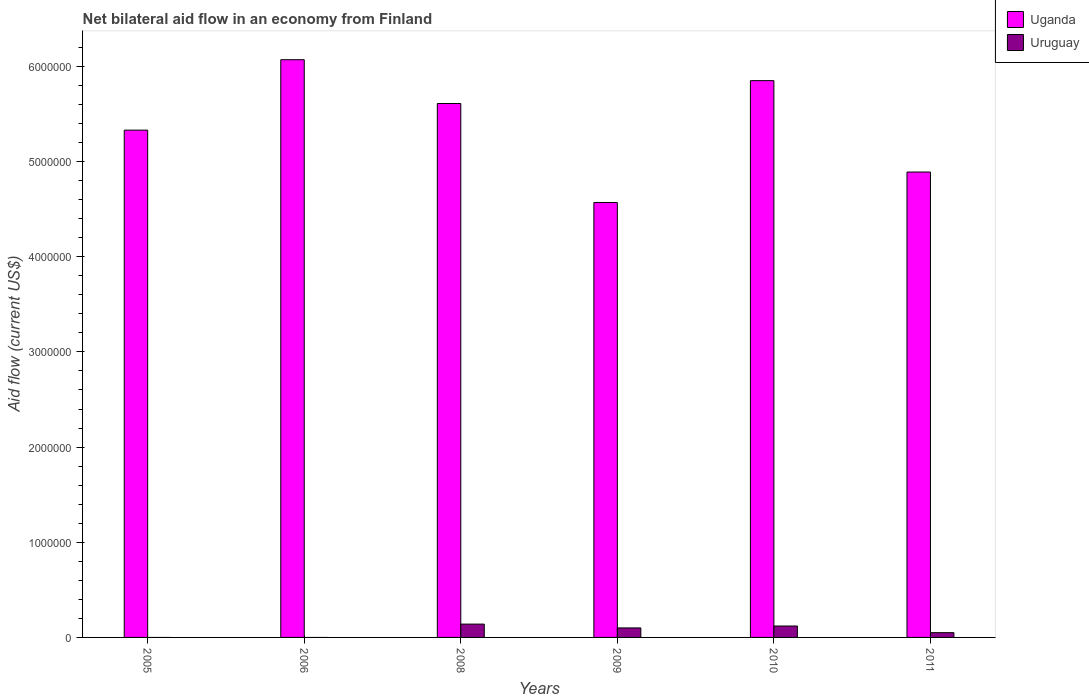Are the number of bars on each tick of the X-axis equal?
Keep it short and to the point. No. What is the label of the 1st group of bars from the left?
Ensure brevity in your answer.  2005. What is the net bilateral aid flow in Uganda in 2009?
Your answer should be compact. 4.57e+06. Across all years, what is the maximum net bilateral aid flow in Uruguay?
Provide a short and direct response. 1.40e+05. Across all years, what is the minimum net bilateral aid flow in Uganda?
Offer a terse response. 4.57e+06. What is the difference between the net bilateral aid flow in Uganda in 2011 and the net bilateral aid flow in Uruguay in 2008?
Offer a very short reply. 4.75e+06. What is the average net bilateral aid flow in Uganda per year?
Keep it short and to the point. 5.39e+06. In the year 2009, what is the difference between the net bilateral aid flow in Uruguay and net bilateral aid flow in Uganda?
Make the answer very short. -4.47e+06. What is the ratio of the net bilateral aid flow in Uganda in 2005 to that in 2006?
Make the answer very short. 0.88. Is the net bilateral aid flow in Uganda in 2010 less than that in 2011?
Offer a terse response. No. Is the difference between the net bilateral aid flow in Uruguay in 2008 and 2009 greater than the difference between the net bilateral aid flow in Uganda in 2008 and 2009?
Make the answer very short. No. What is the difference between the highest and the second highest net bilateral aid flow in Uganda?
Your response must be concise. 2.20e+05. How many bars are there?
Provide a succinct answer. 10. Are all the bars in the graph horizontal?
Your answer should be very brief. No. What is the difference between two consecutive major ticks on the Y-axis?
Your answer should be compact. 1.00e+06. Does the graph contain grids?
Give a very brief answer. No. How many legend labels are there?
Your answer should be very brief. 2. How are the legend labels stacked?
Offer a very short reply. Vertical. What is the title of the graph?
Your answer should be compact. Net bilateral aid flow in an economy from Finland. What is the label or title of the Y-axis?
Provide a succinct answer. Aid flow (current US$). What is the Aid flow (current US$) in Uganda in 2005?
Ensure brevity in your answer.  5.33e+06. What is the Aid flow (current US$) in Uganda in 2006?
Your answer should be compact. 6.07e+06. What is the Aid flow (current US$) in Uganda in 2008?
Ensure brevity in your answer.  5.61e+06. What is the Aid flow (current US$) of Uganda in 2009?
Provide a succinct answer. 4.57e+06. What is the Aid flow (current US$) of Uruguay in 2009?
Offer a very short reply. 1.00e+05. What is the Aid flow (current US$) of Uganda in 2010?
Ensure brevity in your answer.  5.85e+06. What is the Aid flow (current US$) of Uruguay in 2010?
Give a very brief answer. 1.20e+05. What is the Aid flow (current US$) in Uganda in 2011?
Keep it short and to the point. 4.89e+06. Across all years, what is the maximum Aid flow (current US$) in Uganda?
Your response must be concise. 6.07e+06. Across all years, what is the maximum Aid flow (current US$) in Uruguay?
Make the answer very short. 1.40e+05. Across all years, what is the minimum Aid flow (current US$) of Uganda?
Your response must be concise. 4.57e+06. What is the total Aid flow (current US$) of Uganda in the graph?
Offer a terse response. 3.23e+07. What is the total Aid flow (current US$) of Uruguay in the graph?
Offer a very short reply. 4.10e+05. What is the difference between the Aid flow (current US$) of Uganda in 2005 and that in 2006?
Provide a short and direct response. -7.40e+05. What is the difference between the Aid flow (current US$) in Uganda in 2005 and that in 2008?
Provide a succinct answer. -2.80e+05. What is the difference between the Aid flow (current US$) of Uganda in 2005 and that in 2009?
Keep it short and to the point. 7.60e+05. What is the difference between the Aid flow (current US$) in Uganda in 2005 and that in 2010?
Make the answer very short. -5.20e+05. What is the difference between the Aid flow (current US$) in Uganda in 2006 and that in 2008?
Offer a terse response. 4.60e+05. What is the difference between the Aid flow (current US$) of Uganda in 2006 and that in 2009?
Make the answer very short. 1.50e+06. What is the difference between the Aid flow (current US$) of Uganda in 2006 and that in 2010?
Make the answer very short. 2.20e+05. What is the difference between the Aid flow (current US$) in Uganda in 2006 and that in 2011?
Make the answer very short. 1.18e+06. What is the difference between the Aid flow (current US$) of Uganda in 2008 and that in 2009?
Your response must be concise. 1.04e+06. What is the difference between the Aid flow (current US$) in Uganda in 2008 and that in 2011?
Make the answer very short. 7.20e+05. What is the difference between the Aid flow (current US$) of Uruguay in 2008 and that in 2011?
Your answer should be compact. 9.00e+04. What is the difference between the Aid flow (current US$) in Uganda in 2009 and that in 2010?
Keep it short and to the point. -1.28e+06. What is the difference between the Aid flow (current US$) of Uruguay in 2009 and that in 2010?
Keep it short and to the point. -2.00e+04. What is the difference between the Aid flow (current US$) of Uganda in 2009 and that in 2011?
Make the answer very short. -3.20e+05. What is the difference between the Aid flow (current US$) in Uruguay in 2009 and that in 2011?
Keep it short and to the point. 5.00e+04. What is the difference between the Aid flow (current US$) in Uganda in 2010 and that in 2011?
Offer a very short reply. 9.60e+05. What is the difference between the Aid flow (current US$) of Uruguay in 2010 and that in 2011?
Your answer should be very brief. 7.00e+04. What is the difference between the Aid flow (current US$) in Uganda in 2005 and the Aid flow (current US$) in Uruguay in 2008?
Your answer should be very brief. 5.19e+06. What is the difference between the Aid flow (current US$) of Uganda in 2005 and the Aid flow (current US$) of Uruguay in 2009?
Provide a succinct answer. 5.23e+06. What is the difference between the Aid flow (current US$) of Uganda in 2005 and the Aid flow (current US$) of Uruguay in 2010?
Offer a very short reply. 5.21e+06. What is the difference between the Aid flow (current US$) of Uganda in 2005 and the Aid flow (current US$) of Uruguay in 2011?
Ensure brevity in your answer.  5.28e+06. What is the difference between the Aid flow (current US$) of Uganda in 2006 and the Aid flow (current US$) of Uruguay in 2008?
Your response must be concise. 5.93e+06. What is the difference between the Aid flow (current US$) of Uganda in 2006 and the Aid flow (current US$) of Uruguay in 2009?
Make the answer very short. 5.97e+06. What is the difference between the Aid flow (current US$) of Uganda in 2006 and the Aid flow (current US$) of Uruguay in 2010?
Give a very brief answer. 5.95e+06. What is the difference between the Aid flow (current US$) of Uganda in 2006 and the Aid flow (current US$) of Uruguay in 2011?
Offer a terse response. 6.02e+06. What is the difference between the Aid flow (current US$) in Uganda in 2008 and the Aid flow (current US$) in Uruguay in 2009?
Your answer should be very brief. 5.51e+06. What is the difference between the Aid flow (current US$) of Uganda in 2008 and the Aid flow (current US$) of Uruguay in 2010?
Your response must be concise. 5.49e+06. What is the difference between the Aid flow (current US$) of Uganda in 2008 and the Aid flow (current US$) of Uruguay in 2011?
Offer a terse response. 5.56e+06. What is the difference between the Aid flow (current US$) of Uganda in 2009 and the Aid flow (current US$) of Uruguay in 2010?
Offer a terse response. 4.45e+06. What is the difference between the Aid flow (current US$) of Uganda in 2009 and the Aid flow (current US$) of Uruguay in 2011?
Make the answer very short. 4.52e+06. What is the difference between the Aid flow (current US$) of Uganda in 2010 and the Aid flow (current US$) of Uruguay in 2011?
Your answer should be very brief. 5.80e+06. What is the average Aid flow (current US$) in Uganda per year?
Make the answer very short. 5.39e+06. What is the average Aid flow (current US$) of Uruguay per year?
Your response must be concise. 6.83e+04. In the year 2008, what is the difference between the Aid flow (current US$) in Uganda and Aid flow (current US$) in Uruguay?
Offer a terse response. 5.47e+06. In the year 2009, what is the difference between the Aid flow (current US$) in Uganda and Aid flow (current US$) in Uruguay?
Make the answer very short. 4.47e+06. In the year 2010, what is the difference between the Aid flow (current US$) in Uganda and Aid flow (current US$) in Uruguay?
Your answer should be very brief. 5.73e+06. In the year 2011, what is the difference between the Aid flow (current US$) of Uganda and Aid flow (current US$) of Uruguay?
Make the answer very short. 4.84e+06. What is the ratio of the Aid flow (current US$) of Uganda in 2005 to that in 2006?
Provide a succinct answer. 0.88. What is the ratio of the Aid flow (current US$) in Uganda in 2005 to that in 2008?
Your response must be concise. 0.95. What is the ratio of the Aid flow (current US$) of Uganda in 2005 to that in 2009?
Your response must be concise. 1.17. What is the ratio of the Aid flow (current US$) in Uganda in 2005 to that in 2010?
Ensure brevity in your answer.  0.91. What is the ratio of the Aid flow (current US$) in Uganda in 2005 to that in 2011?
Offer a very short reply. 1.09. What is the ratio of the Aid flow (current US$) of Uganda in 2006 to that in 2008?
Your answer should be compact. 1.08. What is the ratio of the Aid flow (current US$) in Uganda in 2006 to that in 2009?
Keep it short and to the point. 1.33. What is the ratio of the Aid flow (current US$) in Uganda in 2006 to that in 2010?
Your answer should be compact. 1.04. What is the ratio of the Aid flow (current US$) in Uganda in 2006 to that in 2011?
Make the answer very short. 1.24. What is the ratio of the Aid flow (current US$) of Uganda in 2008 to that in 2009?
Offer a terse response. 1.23. What is the ratio of the Aid flow (current US$) of Uruguay in 2008 to that in 2009?
Make the answer very short. 1.4. What is the ratio of the Aid flow (current US$) of Uganda in 2008 to that in 2010?
Ensure brevity in your answer.  0.96. What is the ratio of the Aid flow (current US$) in Uruguay in 2008 to that in 2010?
Provide a succinct answer. 1.17. What is the ratio of the Aid flow (current US$) of Uganda in 2008 to that in 2011?
Your answer should be compact. 1.15. What is the ratio of the Aid flow (current US$) of Uganda in 2009 to that in 2010?
Provide a short and direct response. 0.78. What is the ratio of the Aid flow (current US$) in Uganda in 2009 to that in 2011?
Your answer should be compact. 0.93. What is the ratio of the Aid flow (current US$) of Uruguay in 2009 to that in 2011?
Ensure brevity in your answer.  2. What is the ratio of the Aid flow (current US$) in Uganda in 2010 to that in 2011?
Provide a succinct answer. 1.2. What is the difference between the highest and the lowest Aid flow (current US$) in Uganda?
Offer a very short reply. 1.50e+06. 